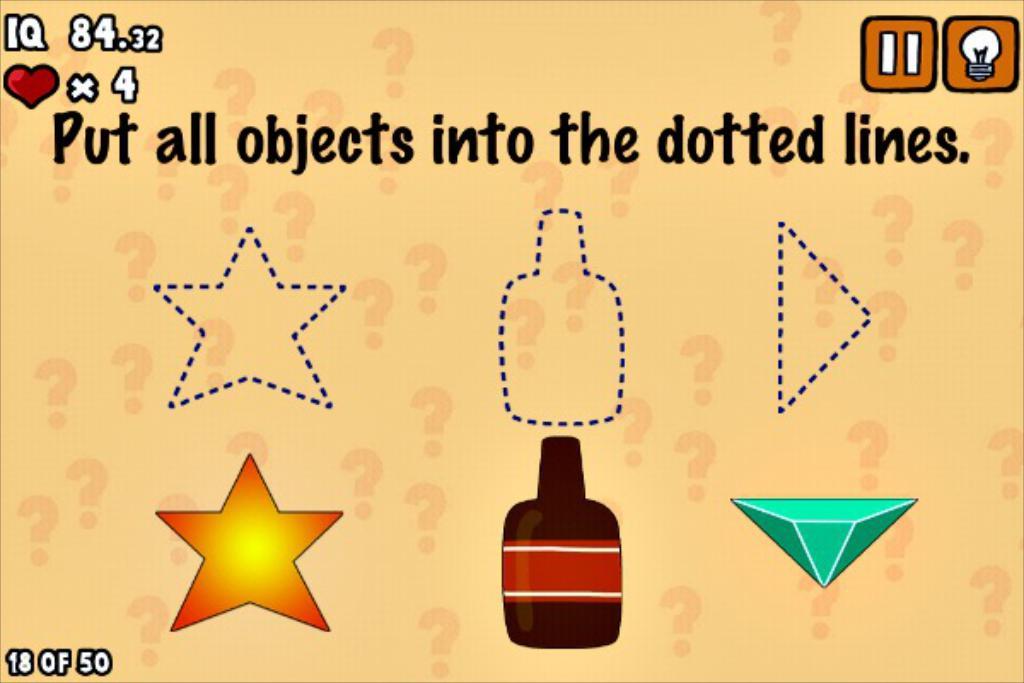How many hearts or lives does this player have left, according to the top left corner?
Provide a succinct answer. 4. 